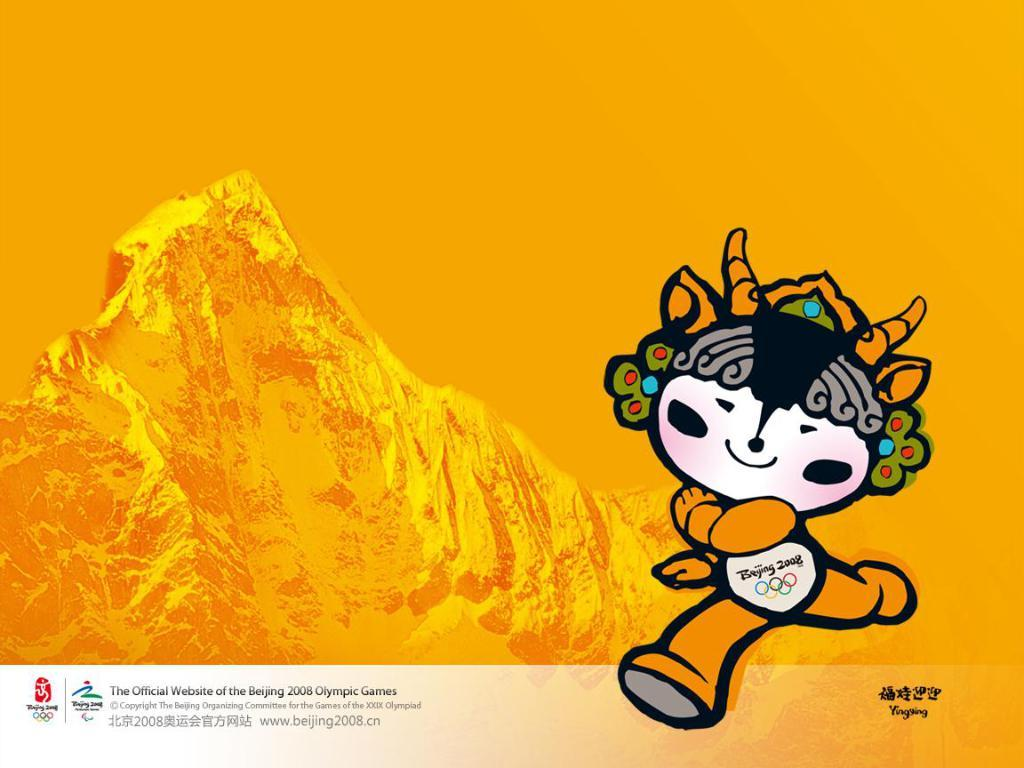What type of image is being described? The image is an animated picture. What geographical feature can be seen in the image? There is a depiction of a mountain in the image. Are there any words or letters in the image? Yes, there is text present in the image. Can you see a cow polishing a hammer in the image? No, there is no cow, polish, or hammer present in the image. 